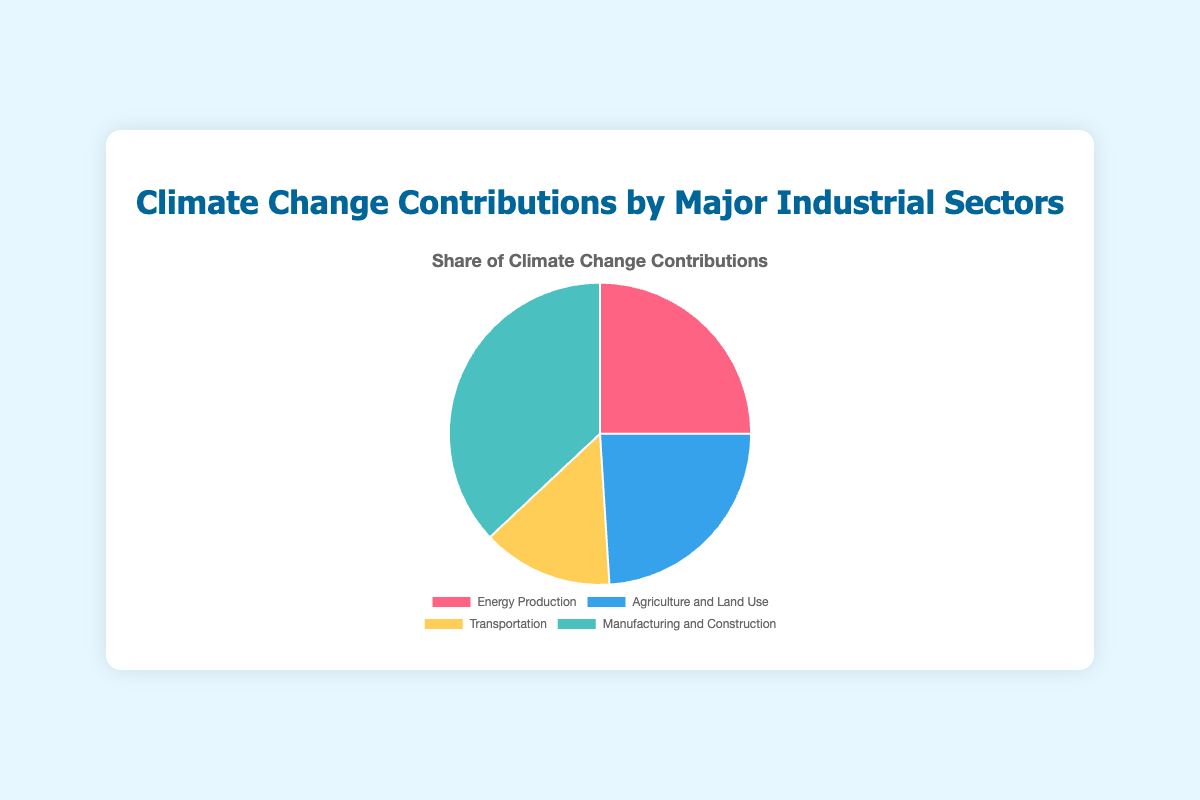What's the share of Manufacturing and Construction in climate change contributions? The figure shows a pie chart with percentage contributions by different industrial sectors. Manufacturing and Construction takes up a portion labeled with 37%. Hence, it contributes 37% to climate change.
Answer: 37% Which sector has the second-highest contribution to climate change? From the pie chart, we can observe the contributions from various sectors labeled with their percentages. Energy Production contributes 25%, Agriculture and Land Use contributes 24%, Transportation 14%, and Manufacturing and Construction 37%. The second-highest contribution is from Energy Production at 25%.
Answer: Energy Production What is the combined contribution percentage of Energy Production and Transportation? In the pie chart, Energy Production is labeled with 25% and Transportation with 14%. Summing these percentages gives us 25% + 14% = 39%.
Answer: 39% Which sector contributes the least to climate change? The pie chart displays the contributions of four sectors with their respective percentages. The smallest percentage is 14% from Transportation.
Answer: Transportation By how much does Manufacturing and Construction's contribution exceed that of Agriculture and Land Use? Manufacturing and Construction has a contribution of 37% and Agriculture and Land Use has 24%, both visible in the pie chart. The difference is calculated as 37% - 24% = 13%.
Answer: 13% If we combine the contributions of Agriculture and Land Use and Transportation, how does their combined contribution compare to the contribution of Energy Production? Agriculture and Land Use contributes 24% and Transportation 14%, which sums up to 38% (24% + 14%). Energy Production contributes 25%. Comparing these figures, the combined 38% is 13% more than 25%.
Answer: 13% more What color represents the Energy Production sector in the pie chart? Referring to the color code shown in the pie chart, we see that Energy Production is represented by a red color segment.
Answer: Red How much more does Manufacturing and Construction contribute compared to Transportation? From the pie chart, Manufacturing and Construction contributes 37%, and Transportation contributes 14%. The difference is calculated as 37% - 14% = 23%.
Answer: 23% What is the contribution percentage if we sum all sectors except Manufacturing and Construction? Adding up the contributions of Energy Production (25%), Agriculture and Land Use (24%), and Transportation (14%) gives us a total of 25% + 24% + 14% = 63%.
Answer: 63% 